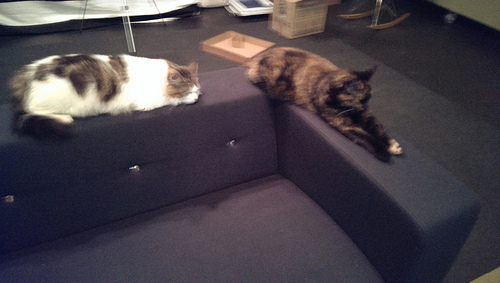<image>
Can you confirm if the cat is on the floor? No. The cat is not positioned on the floor. They may be near each other, but the cat is not supported by or resting on top of the floor. Where is the cat in relation to the couch? Is it behind the couch? No. The cat is not behind the couch. From this viewpoint, the cat appears to be positioned elsewhere in the scene. 